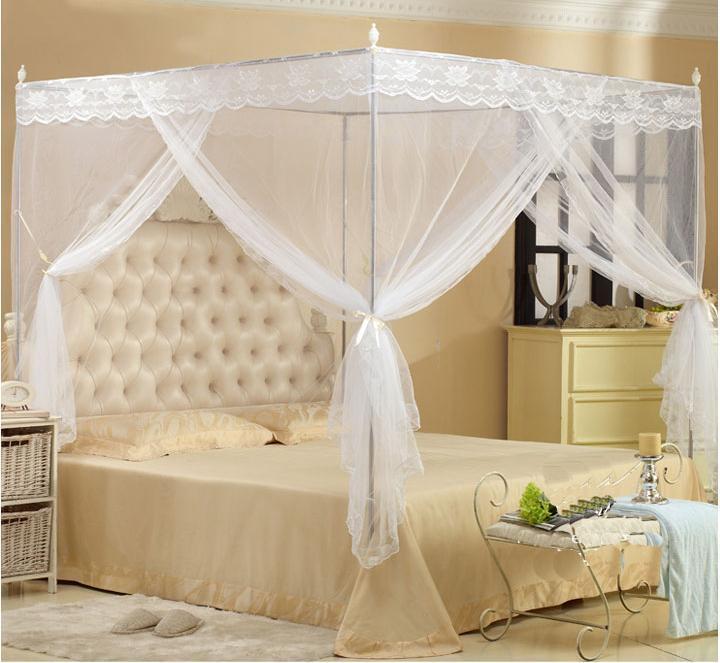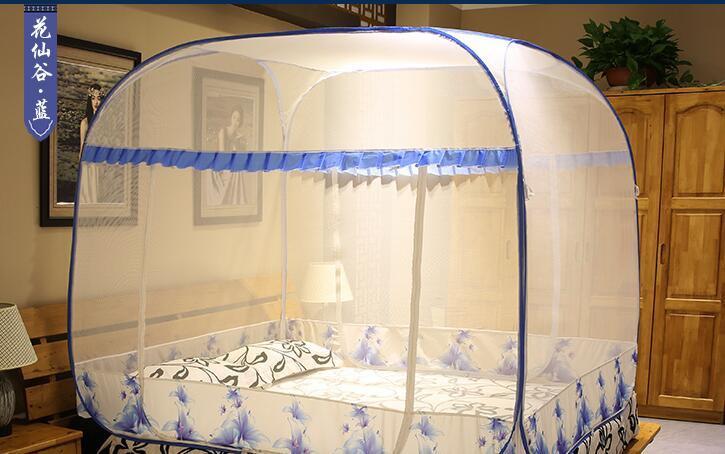The first image is the image on the left, the second image is the image on the right. Examine the images to the left and right. Is the description "The bed in the image on the right is covered by a curved tent." accurate? Answer yes or no. Yes. The first image is the image on the left, the second image is the image on the right. Examine the images to the left and right. Is the description "Exactly one bed has corner posts." accurate? Answer yes or no. Yes. 